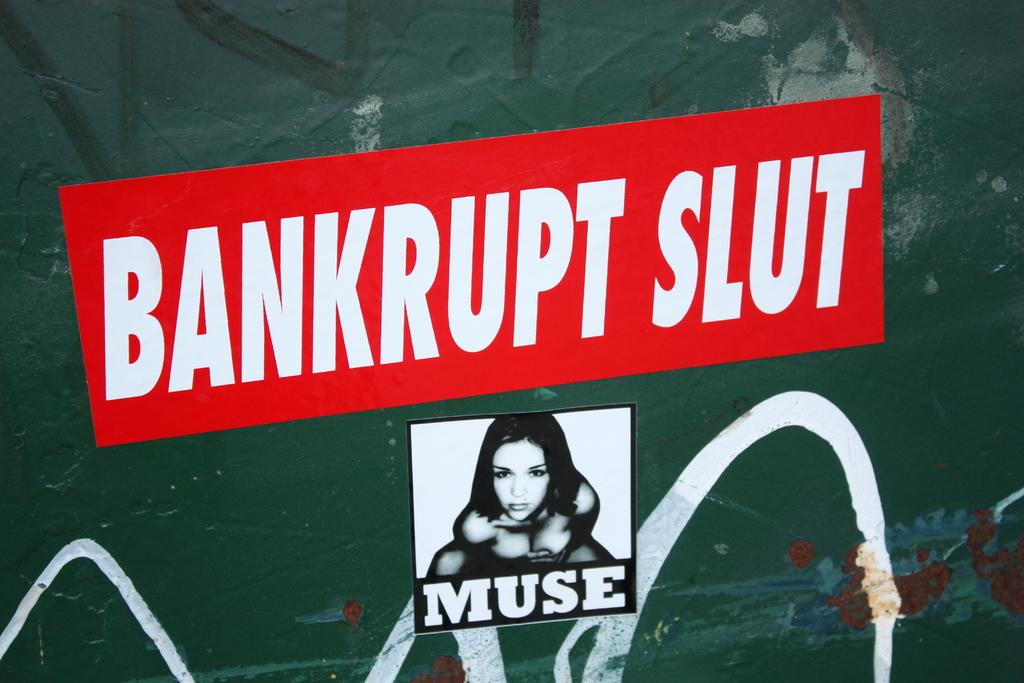Does this signal a warning?
Give a very brief answer. No. What words are written at the bottom of the girls picture?
Give a very brief answer. Muse. 